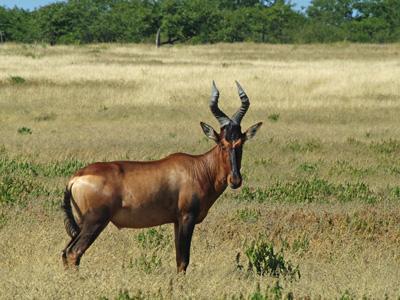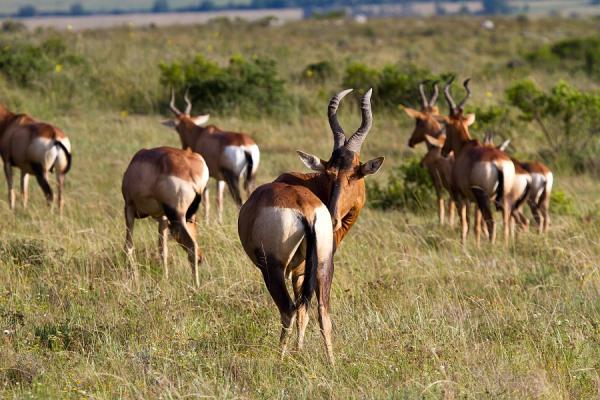The first image is the image on the left, the second image is the image on the right. Given the left and right images, does the statement "An image shows exactly two antelope that are not sparring." hold true? Answer yes or no. No. 